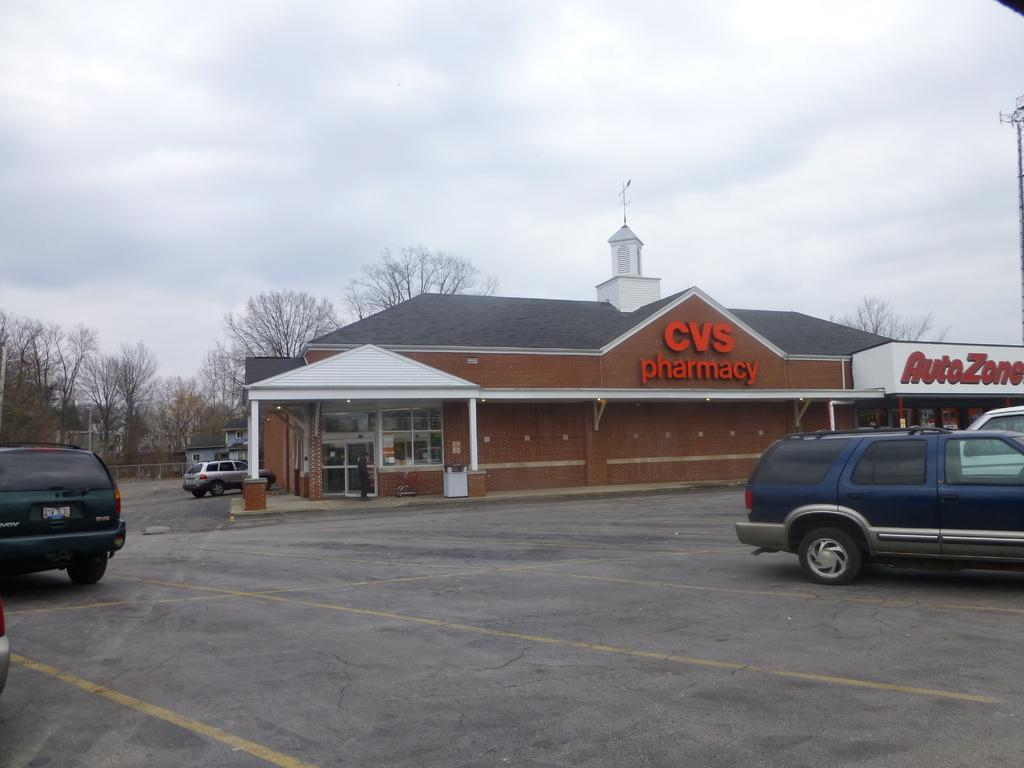What types of vehicles are on the ground in the image? There are vehicles on the ground in the image, but the specific types cannot be determined from the provided facts. What can be seen in the background of the image? There is a building and the sky visible in the background of the image. What else is present on the ground in the background of the image? There are other objects on the ground in the background of the image, but their nature cannot be determined from the provided facts. What type of card is being used to balance the engine in the image? There is no card or engine present in the image; it features vehicles on the ground and a building in the background. 